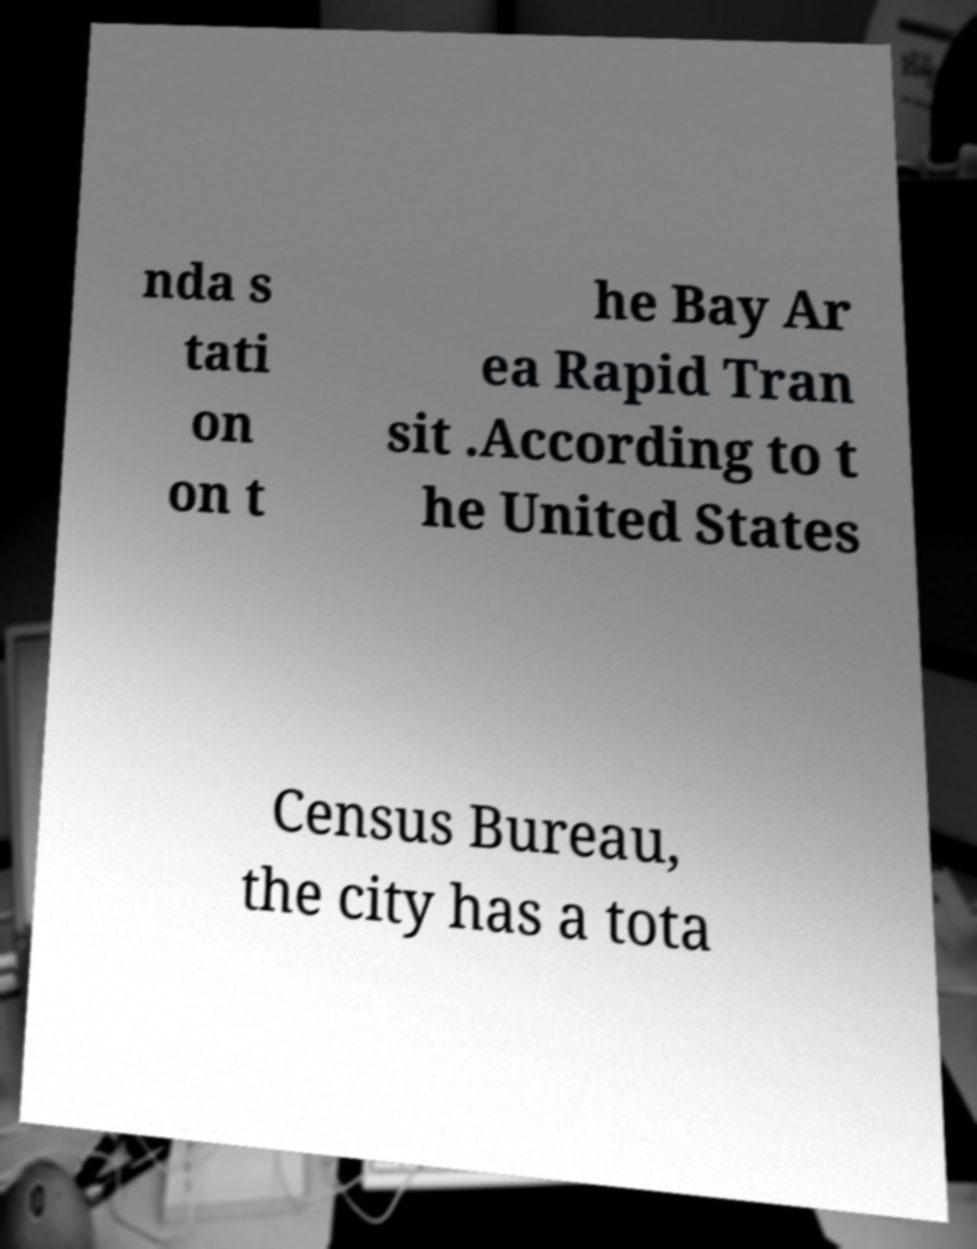Can you accurately transcribe the text from the provided image for me? nda s tati on on t he Bay Ar ea Rapid Tran sit .According to t he United States Census Bureau, the city has a tota 